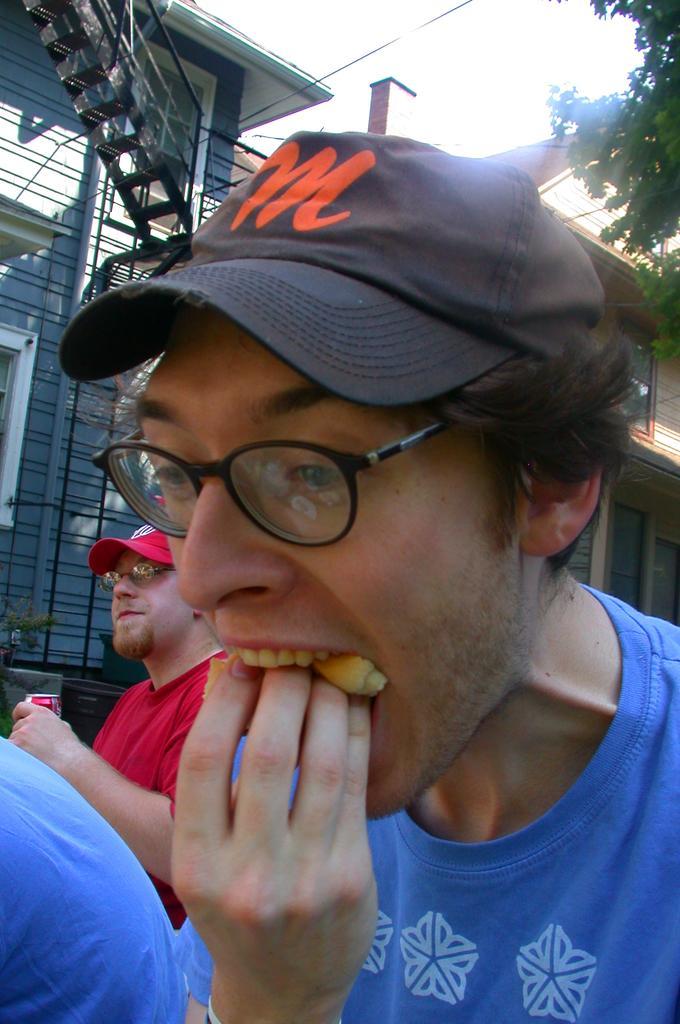In one or two sentences, can you explain what this image depicts? In this image a person wearing a blue shirt is keeping some food in his mouth with his hand. He is wearing spectacles and cap. Beside there is a person wearing a red shirt. He is holding coke can and he is wearing spectacles and red cap. Left bottom there is a person wearing a blue shirt. Behind them there is a building. Right top there is a tree having leaves. Top of image there is sky. 